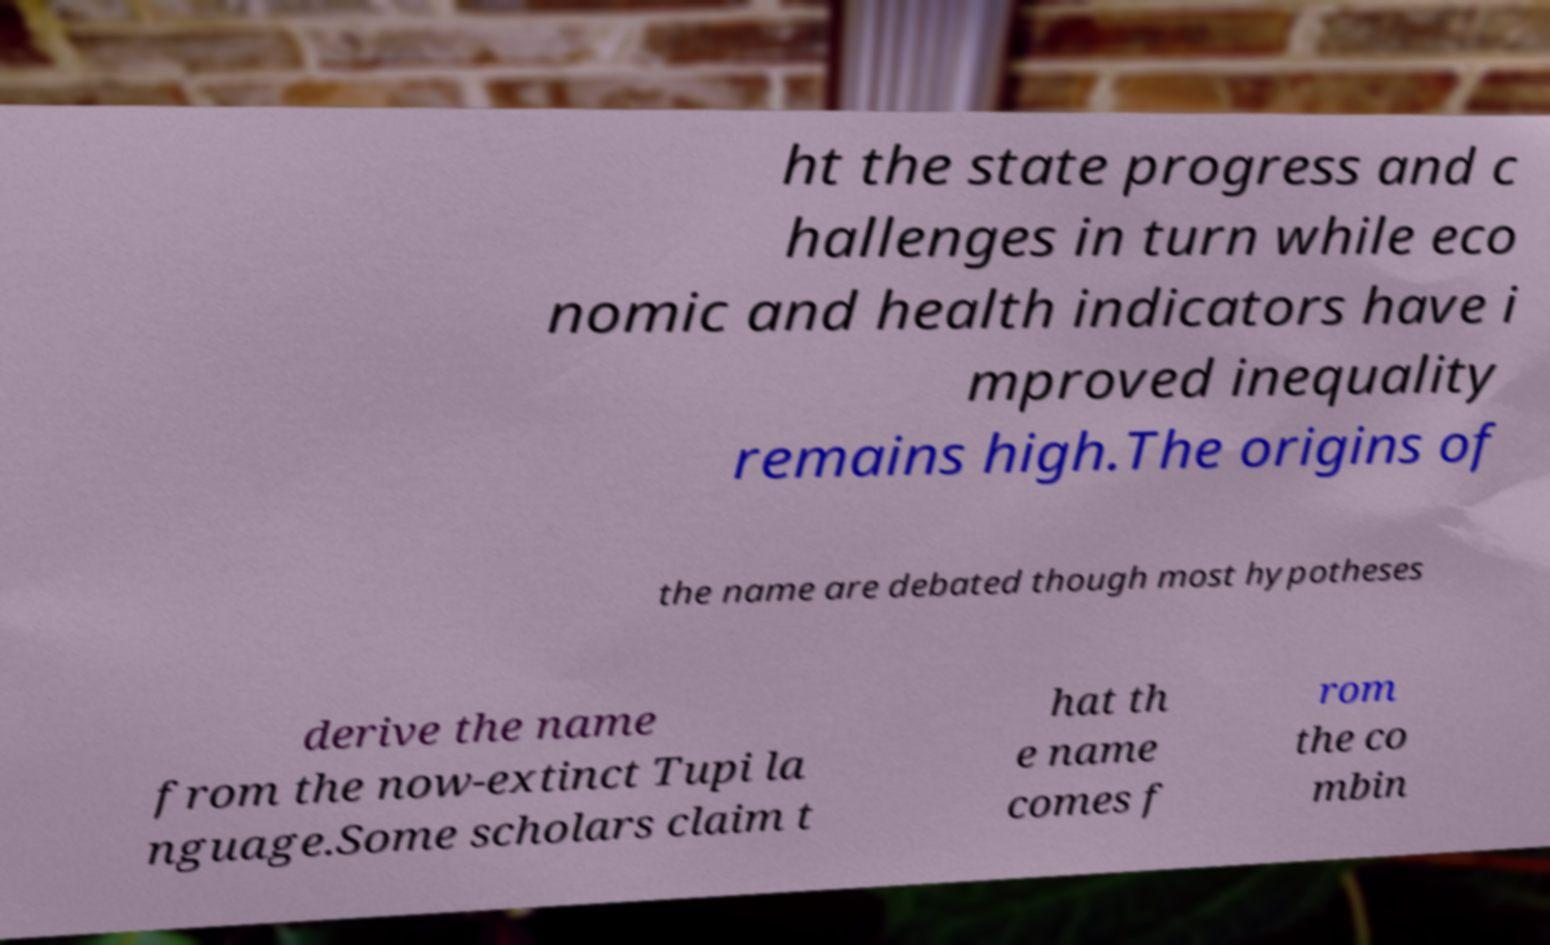Can you read and provide the text displayed in the image?This photo seems to have some interesting text. Can you extract and type it out for me? ht the state progress and c hallenges in turn while eco nomic and health indicators have i mproved inequality remains high.The origins of the name are debated though most hypotheses derive the name from the now-extinct Tupi la nguage.Some scholars claim t hat th e name comes f rom the co mbin 